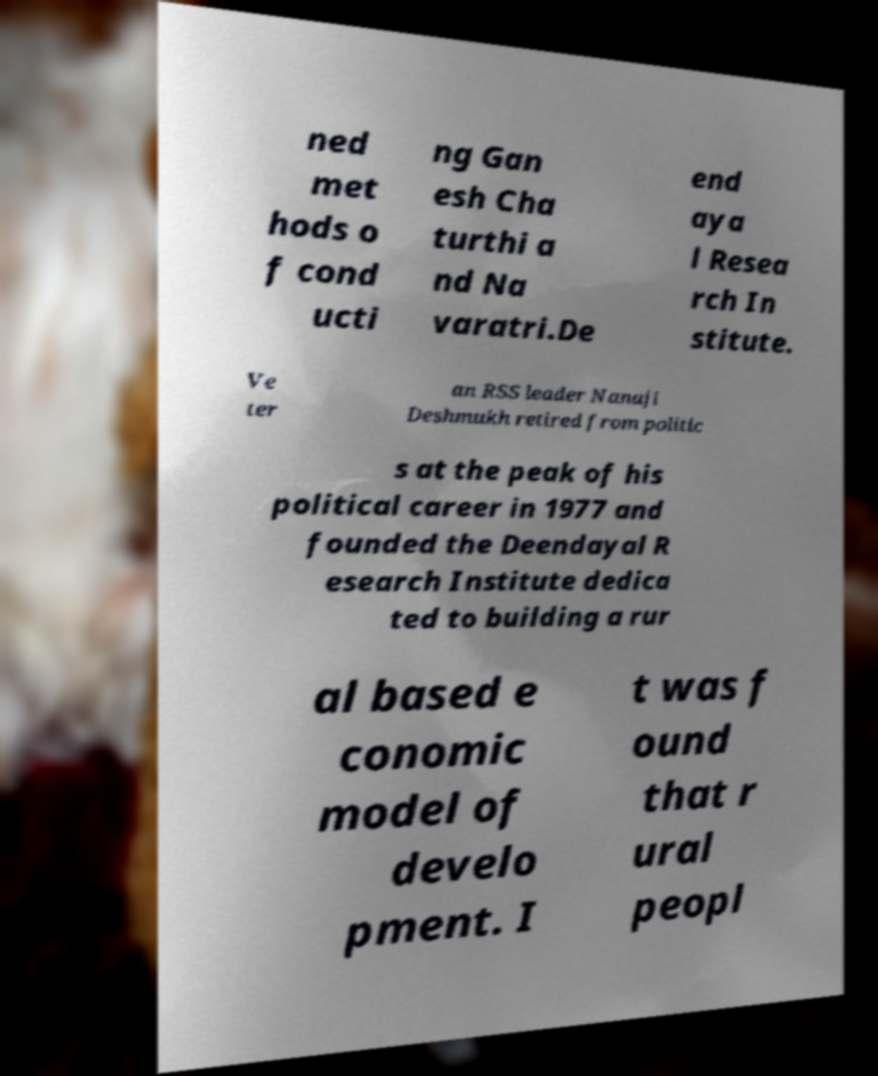There's text embedded in this image that I need extracted. Can you transcribe it verbatim? ned met hods o f cond ucti ng Gan esh Cha turthi a nd Na varatri.De end aya l Resea rch In stitute. Ve ter an RSS leader Nanaji Deshmukh retired from politic s at the peak of his political career in 1977 and founded the Deendayal R esearch Institute dedica ted to building a rur al based e conomic model of develo pment. I t was f ound that r ural peopl 